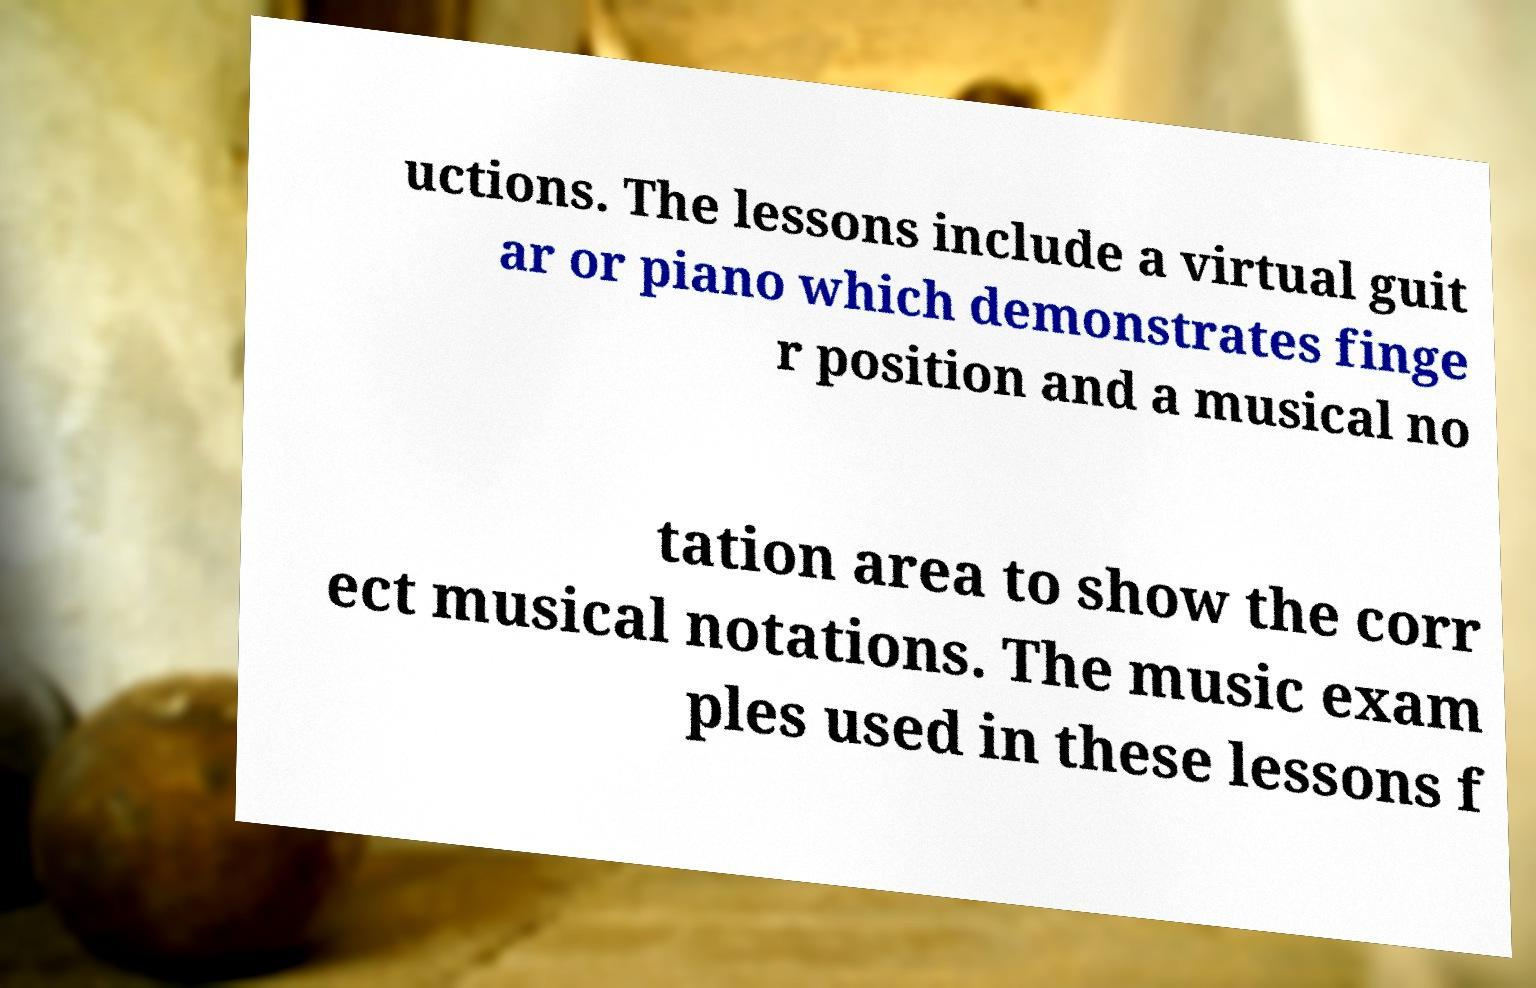For documentation purposes, I need the text within this image transcribed. Could you provide that? uctions. The lessons include a virtual guit ar or piano which demonstrates finge r position and a musical no tation area to show the corr ect musical notations. The music exam ples used in these lessons f 